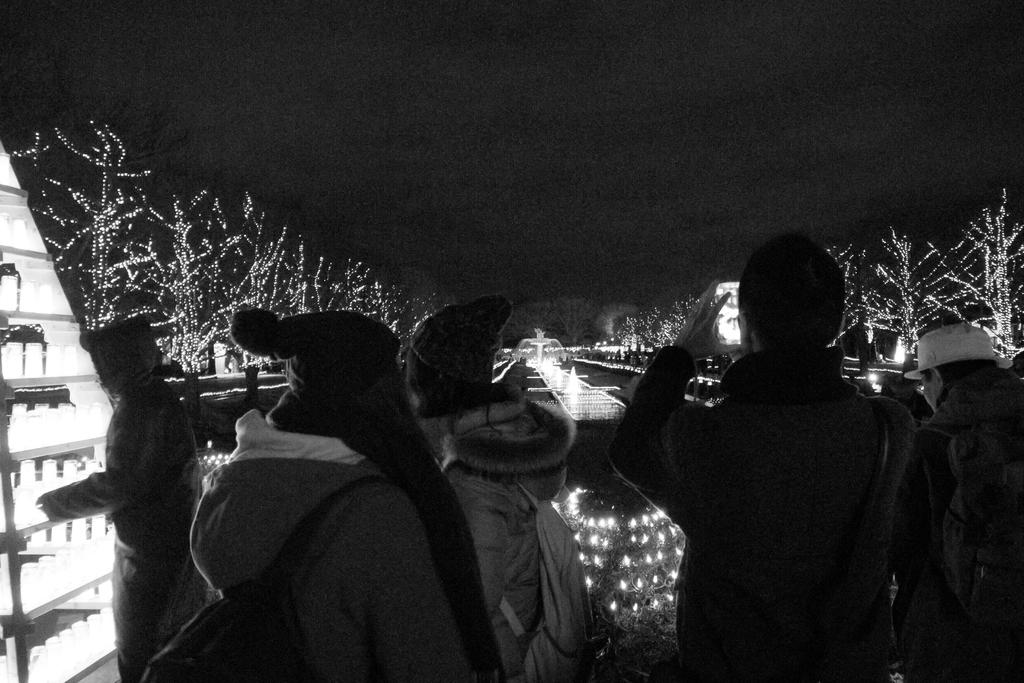What is the color scheme of the image? The image is black and white. How many people can be seen in the image? There are a few people in the image. What is visible in the background of the image? The sky and trees are visible in the image. What is the ground like in the image? The ground is visible in the image. Are there any artificial light sources in the image? Yes, there are lights in the image. What is located on the left side of the image? There are objects on the left side of the image. How many horses are grazing in the farm depicted in the image? There is no farm or horses present in the image; it is a black and white image with a few people, trees, lights, and objects. 